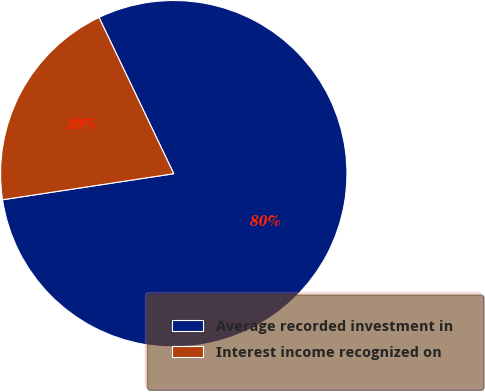<chart> <loc_0><loc_0><loc_500><loc_500><pie_chart><fcel>Average recorded investment in<fcel>Interest income recognized on<nl><fcel>79.7%<fcel>20.3%<nl></chart> 